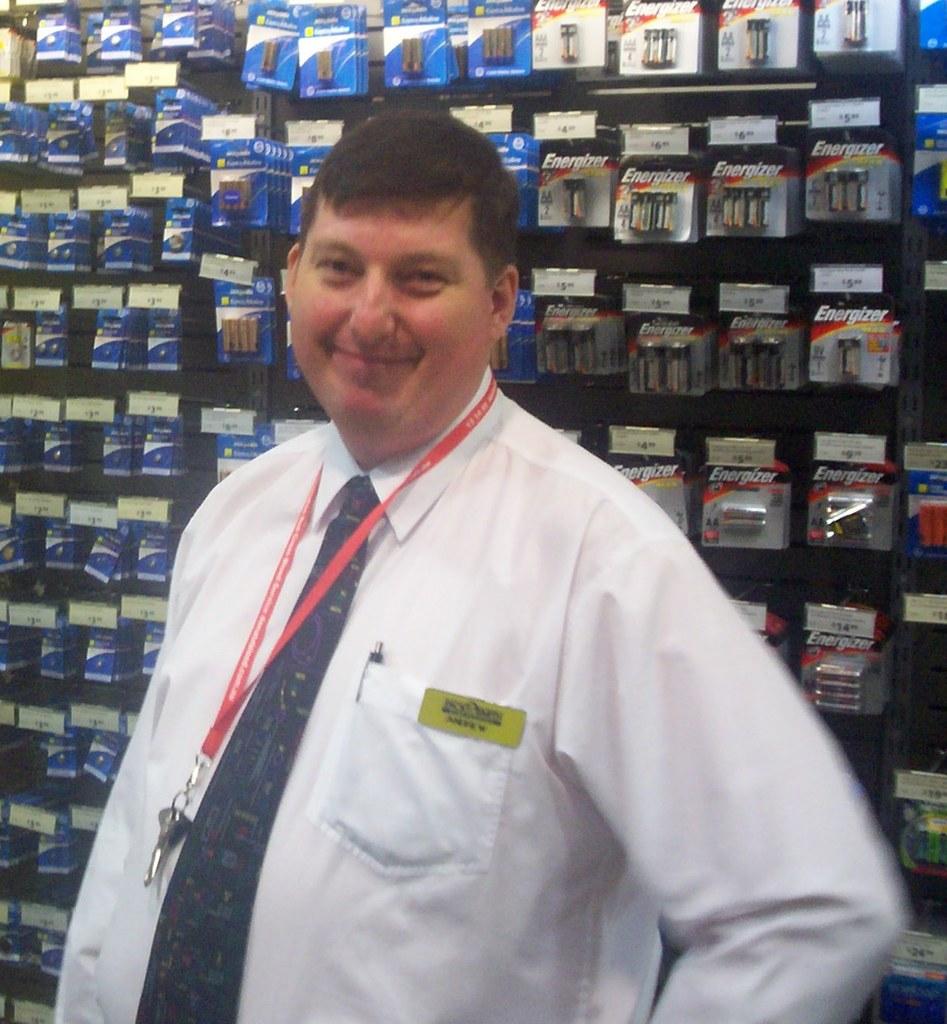What brand of batteries are in the gray packages?
Offer a terse response. Energizer. 